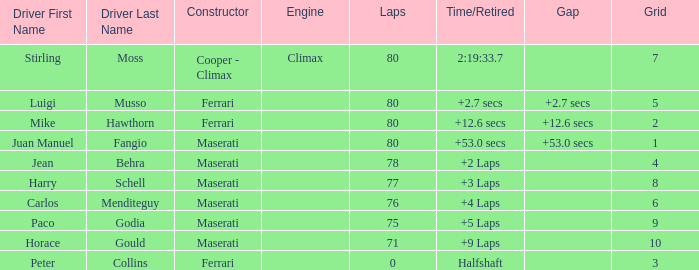What were the lowest laps of Luigi Musso driving a Ferrari with a Grid larger than 2? 80.0. 